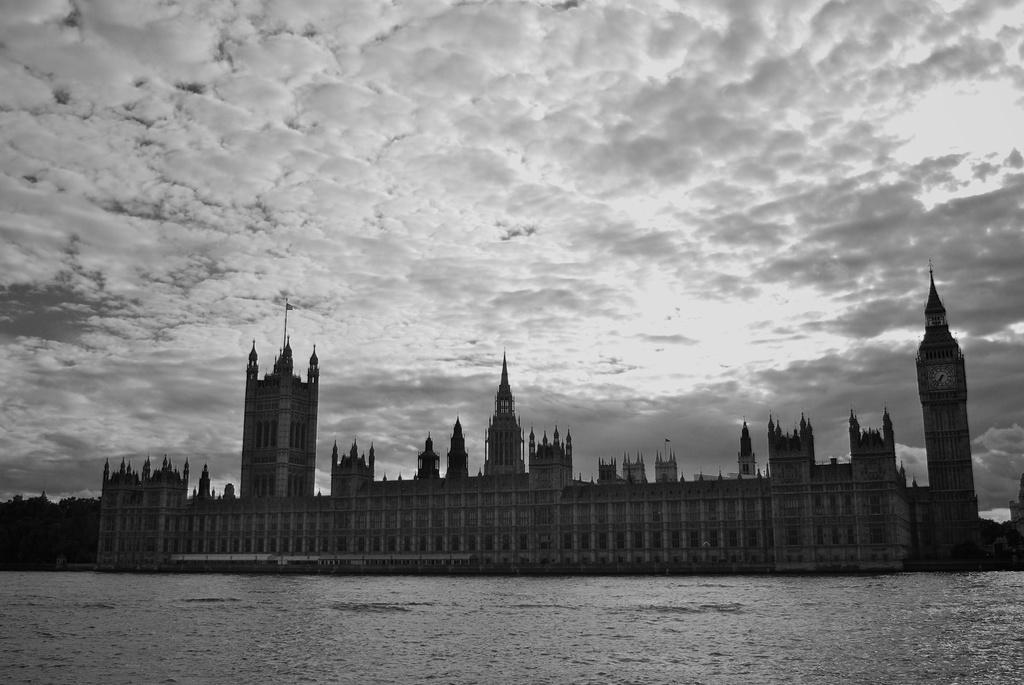Can you describe this image briefly? This is a black and white picture. I can see water. There are buildings, trees, clock tower, and in the background there is the sky. 